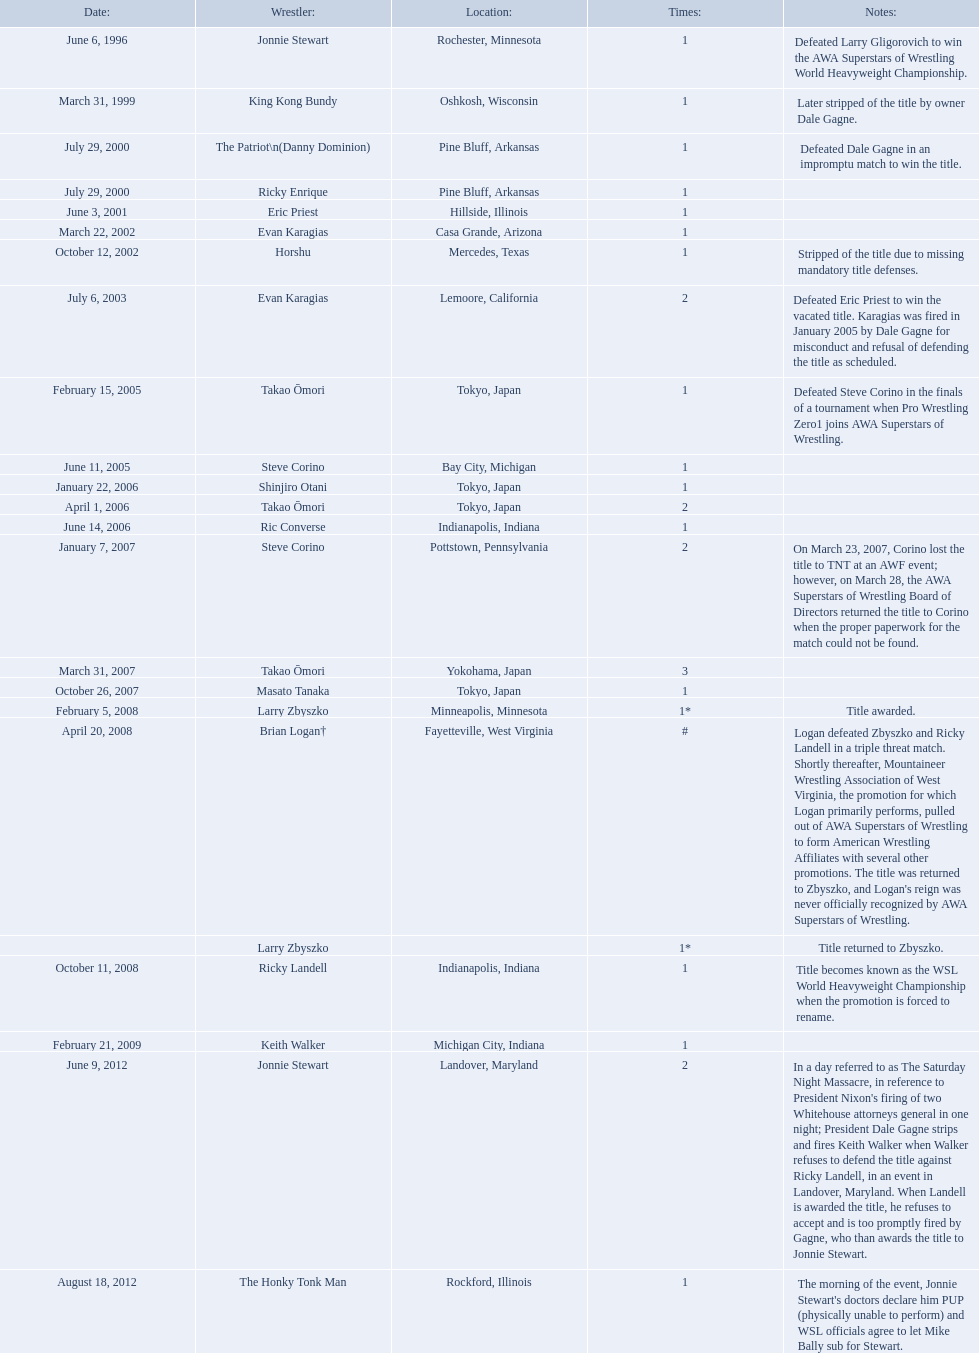Who are the wrestlers? Jonnie Stewart, Rochester, Minnesota, King Kong Bundy, Oshkosh, Wisconsin, The Patriot\n(Danny Dominion), Pine Bluff, Arkansas, Ricky Enrique, Pine Bluff, Arkansas, Eric Priest, Hillside, Illinois, Evan Karagias, Casa Grande, Arizona, Horshu, Mercedes, Texas, Evan Karagias, Lemoore, California, Takao Ōmori, Tokyo, Japan, Steve Corino, Bay City, Michigan, Shinjiro Otani, Tokyo, Japan, Takao Ōmori, Tokyo, Japan, Ric Converse, Indianapolis, Indiana, Steve Corino, Pottstown, Pennsylvania, Takao Ōmori, Yokohama, Japan, Masato Tanaka, Tokyo, Japan, Larry Zbyszko, Minneapolis, Minnesota, Brian Logan†, Fayetteville, West Virginia, Larry Zbyszko, , Ricky Landell, Indianapolis, Indiana, Keith Walker, Michigan City, Indiana, Jonnie Stewart, Landover, Maryland, The Honky Tonk Man, Rockford, Illinois. Who was from texas? Horshu, Mercedes, Texas. Who is he? Horshu. 